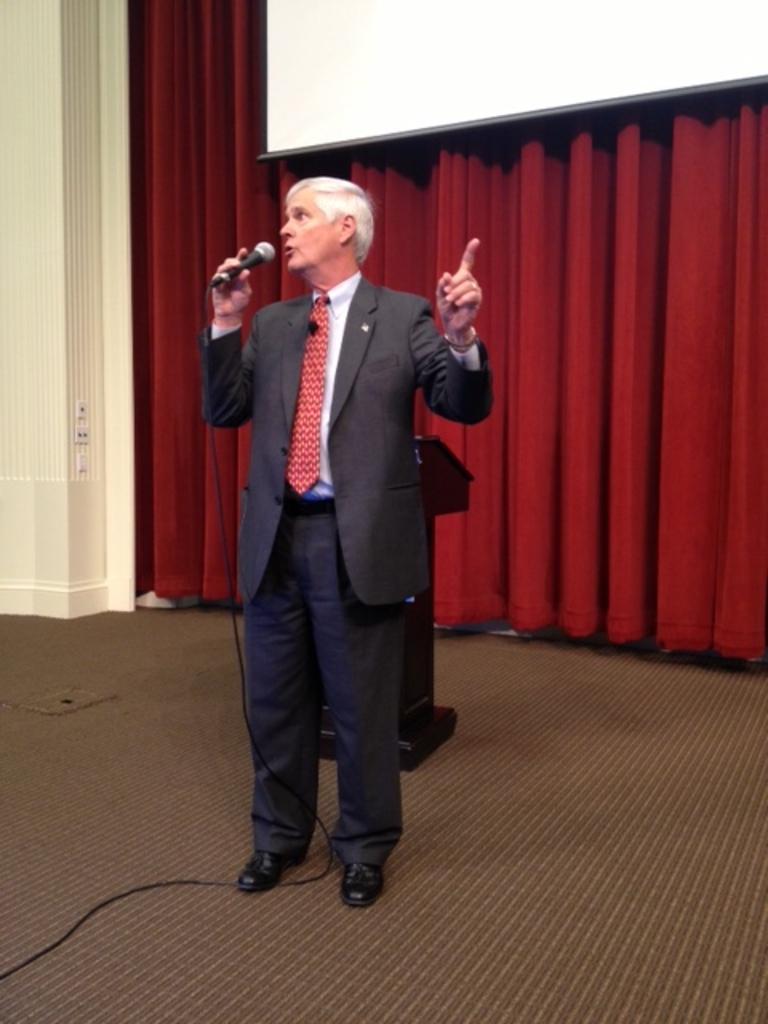Can you describe this image briefly? In the image we can see there is a person standing and he is wearing formal suit. The man is holding mic in his hand and behind there is podium kept on the ground. There is red colour curtain on the wall. 